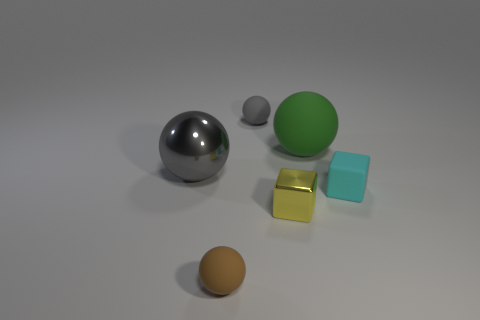Subtract all cyan cubes. How many gray balls are left? 2 Subtract all large gray metallic balls. How many balls are left? 3 Add 2 large gray metallic spheres. How many objects exist? 8 Subtract 2 balls. How many balls are left? 2 Subtract all brown spheres. How many spheres are left? 3 Subtract all blocks. How many objects are left? 4 Subtract all red balls. Subtract all green blocks. How many balls are left? 4 Add 5 yellow metallic blocks. How many yellow metallic blocks exist? 6 Subtract 1 green spheres. How many objects are left? 5 Subtract all big blocks. Subtract all tiny gray matte balls. How many objects are left? 5 